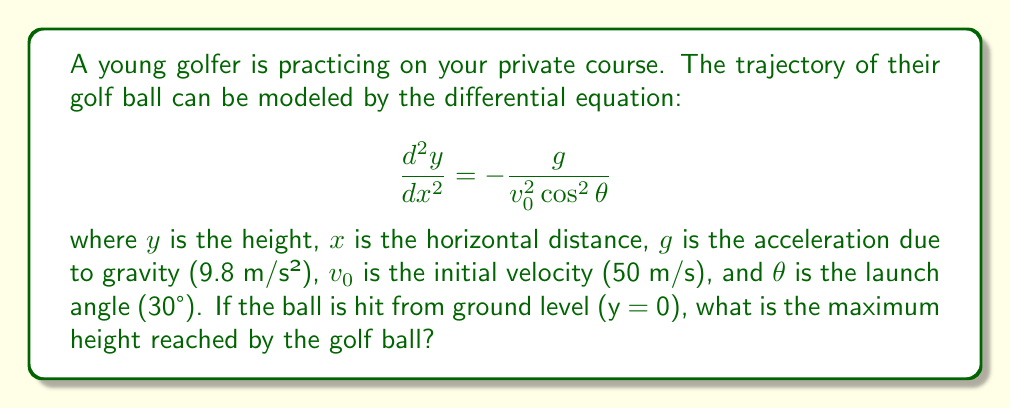What is the answer to this math problem? To solve this problem, we'll follow these steps:

1) First, we need to integrate the given differential equation twice to get the equation for y(x).

2) Integrating once gives us:

   $$\frac{dy}{dx} = -\frac{g}{v_0^2 \cos^2 \theta}x + C_1$$

3) Integrating again:

   $$y = -\frac{g}{2v_0^2 \cos^2 \theta}x^2 + C_1x + C_2$$

4) We can find $C_1$ and $C_2$ using initial conditions. We know that at x = 0, y = 0 and $\frac{dy}{dx} = \tan \theta$. Applying these:

   $$C_2 = 0$$
   $$C_1 = \tan \theta$$

5) So our equation for y(x) is:

   $$y = -\frac{g}{2v_0^2 \cos^2 \theta}x^2 + (\tan \theta)x$$

6) To find the maximum height, we need to find where $\frac{dy}{dx} = 0$:

   $$\frac{dy}{dx} = -\frac{g}{v_0^2 \cos^2 \theta}x + \tan \theta = 0$$

7) Solving for x:

   $$x = \frac{v_0^2 \sin \theta \cos \theta}{g}$$

8) Substituting this x back into our equation for y(x):

   $$y_{max} = -\frac{g}{2v_0^2 \cos^2 \theta} \cdot (\frac{v_0^2 \sin \theta \cos \theta}{g})^2 + (\tan \theta) \cdot \frac{v_0^2 \sin \theta \cos \theta}{g}$$

9) Simplifying:

   $$y_{max} = \frac{v_0^2 \sin^2 \theta}{2g}$$

10) Now we can plug in our values: $v_0 = 50$ m/s, $\theta = 30°$, $g = 9.8$ m/s²

    $$y_{max} = \frac{50^2 \sin^2 30°}{2 \cdot 9.8} \approx 31.89 \text{ m}$$
Answer: 31.89 m 